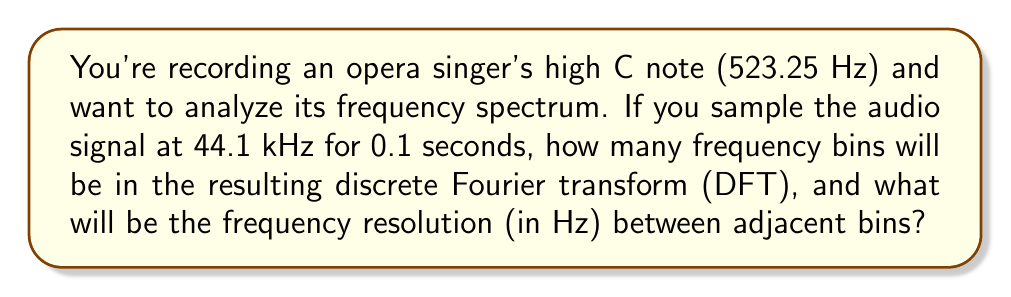Give your solution to this math problem. To solve this problem, we need to understand the relationship between the time domain signal and its frequency domain representation through the Fourier transform. Let's break it down step-by-step:

1. Determine the number of samples:
   - Sampling rate = 44.1 kHz = 44,100 samples/second
   - Duration = 0.1 seconds
   - Number of samples, $N = 44,100 \times 0.1 = 4,410$ samples

2. Number of frequency bins:
   The DFT produces $N$ complex output points, where $N$ is the number of input samples. However, due to symmetry in the output for real-valued inputs, we typically only consider the first $N/2 + 1$ points (including DC and Nyquist frequency).

   Number of frequency bins = $\frac{N}{2} + 1 = \frac{4,410}{2} + 1 = 2,206$ bins

3. Frequency resolution:
   The frequency resolution, $\Delta f$, is the spacing between adjacent frequency bins. It's calculated as:

   $$\Delta f = \frac{f_s}{N}$$

   Where $f_s$ is the sampling frequency and $N$ is the number of samples.

   $$\Delta f = \frac{44,100}{4,410} = 10 \text{ Hz}$$

This resolution allows you to distinguish frequency components that are at least 10 Hz apart, which is crucial for analyzing the rich harmonics in an opera singer's voice.
Answer: Number of frequency bins: 2,206
Frequency resolution: 10 Hz 